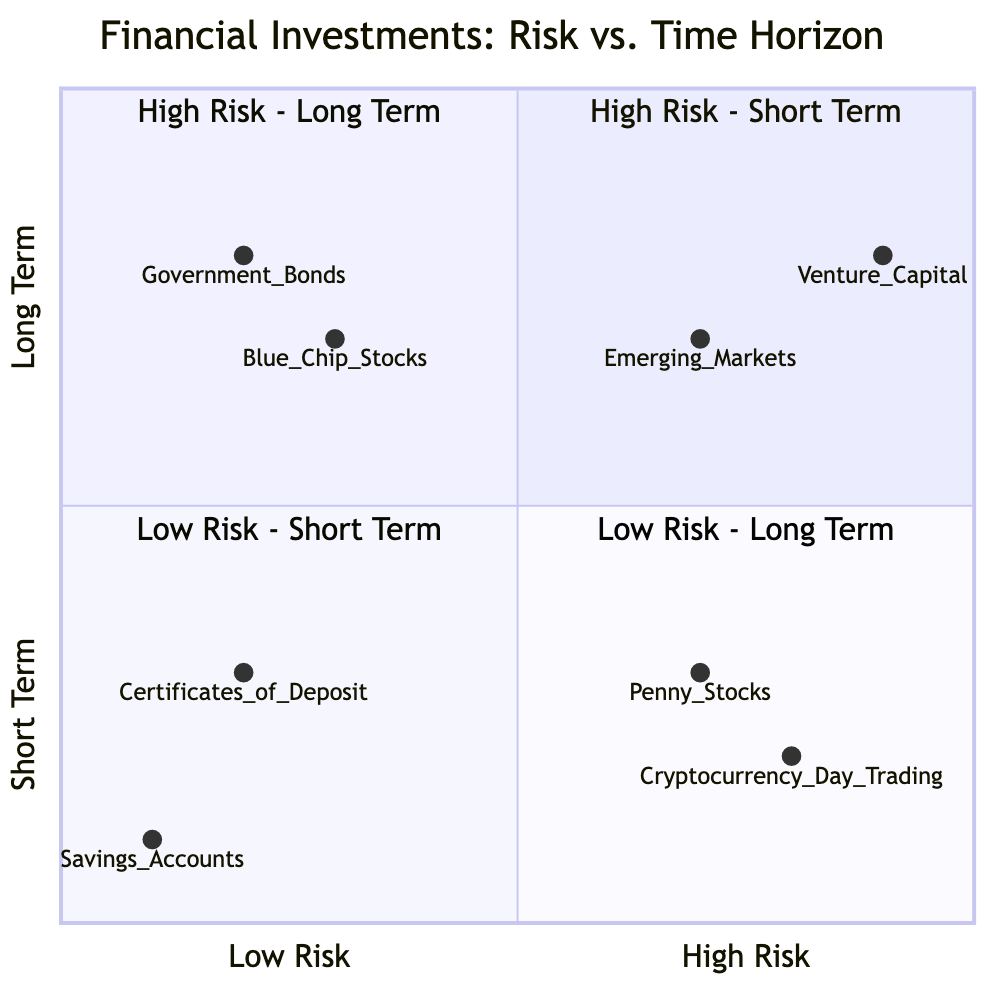What are the two investments listed under High Risk - Short Term? The High Risk - Short Term quadrant shows two investments: Cryptocurrency Day Trading and Penny Stocks.
Answer: Cryptocurrency Day Trading, Penny Stocks Which investment in the Low Risk - Long Term quadrant is considered very low risk? Government Bonds are the investment indicated in the Low Risk - Long Term quadrant that is considered very low risk, as they are debt securities issued by governments.
Answer: Government Bonds How many investment types are listed overall in this diagram? There are eight investment types total, consisting of two from each of the four quadrants.
Answer: 8 Which investment has the highest risk and longest term according to the diagram? Venture Capital is located in the High Risk - Long Term quadrant, indicating it has the highest risk and longest investment term in the diagram.
Answer: Venture Capital In the Low Risk - Short Term quadrant, how many options are available? The Low Risk - Short Term quadrant features two investment options: Savings Accounts and Certificates of Deposit.
Answer: 2 What is the primary difference between Blue Chip Stocks and Penny Stocks based on their quadrants? Blue Chip Stocks are categorized in the Low Risk - Long Term quadrant while Penny Stocks are categorized in the High Risk - Short Term quadrant, showing a difference in risk level and investment duration.
Answer: Risk level, duration How many investments are classified as Long Term across all quadrants? There are four investments classified as Long Term: Venture Capital, Emerging Markets, Government Bonds, and Blue Chip Stocks – two from High Risk and two from Low Risk.
Answer: 4 Which investment has the lowest risk in the Short Term category? Savings Accounts represent the investment with the lowest risk in the Low Risk - Short Term quadrant.
Answer: Savings Accounts 